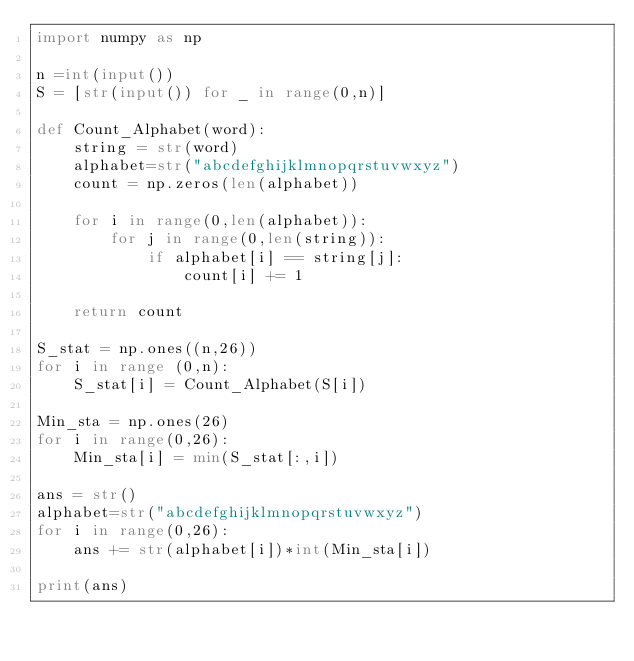Convert code to text. <code><loc_0><loc_0><loc_500><loc_500><_Python_>import numpy as np

n =int(input())
S = [str(input()) for _ in range(0,n)]

def Count_Alphabet(word):
    string = str(word)
    alphabet=str("abcdefghijklmnopqrstuvwxyz")
    count = np.zeros(len(alphabet))
    
    for i in range(0,len(alphabet)):
        for j in range(0,len(string)):
            if alphabet[i] == string[j]:
                count[i] += 1
    
    return count
  
S_stat = np.ones((n,26))
for i in range (0,n):
    S_stat[i] = Count_Alphabet(S[i])
    
Min_sta = np.ones(26)
for i in range(0,26):
    Min_sta[i] = min(S_stat[:,i])
    
ans = str()
alphabet=str("abcdefghijklmnopqrstuvwxyz")
for i in range(0,26):
    ans += str(alphabet[i])*int(Min_sta[i])

print(ans)</code> 